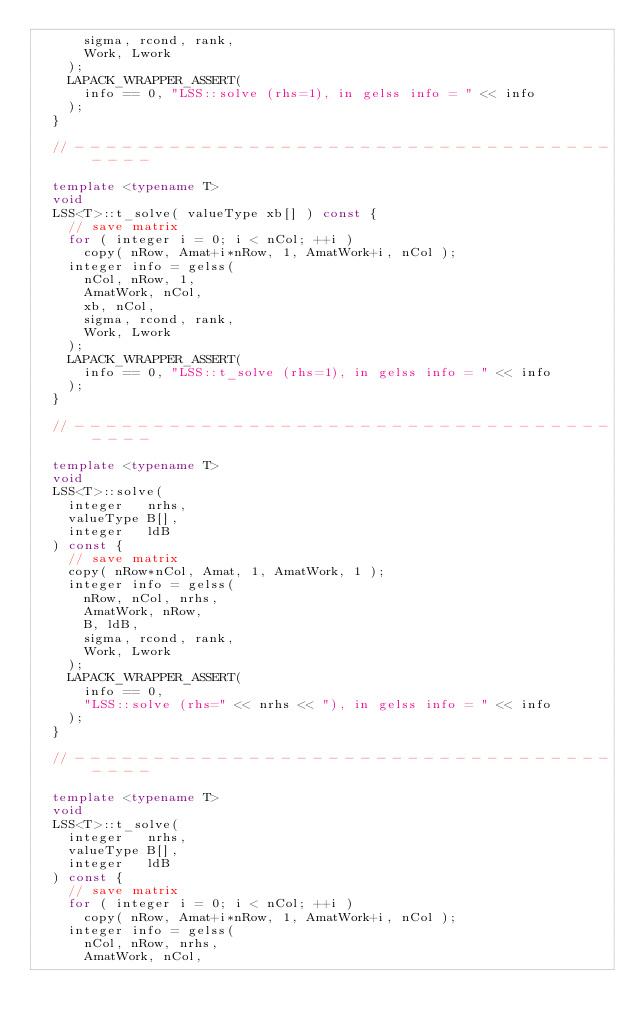Convert code to text. <code><loc_0><loc_0><loc_500><loc_500><_C++_>      sigma, rcond, rank,
      Work, Lwork
    );
    LAPACK_WRAPPER_ASSERT(
      info == 0, "LSS::solve (rhs=1), in gelss info = " << info
    );
  }

  // - - - - - - - - - - - - - - - - - - - - - - - - - - - - - - - - - - - - - -

  template <typename T>
  void
  LSS<T>::t_solve( valueType xb[] ) const {
    // save matrix
    for ( integer i = 0; i < nCol; ++i )
      copy( nRow, Amat+i*nRow, 1, AmatWork+i, nCol );
    integer info = gelss(
      nCol, nRow, 1,
      AmatWork, nCol,
      xb, nCol,
      sigma, rcond, rank,
      Work, Lwork
    );
    LAPACK_WRAPPER_ASSERT(
      info == 0, "LSS::t_solve (rhs=1), in gelss info = " << info
    );
  }

  // - - - - - - - - - - - - - - - - - - - - - - - - - - - - - - - - - - - - - -

  template <typename T>
  void
  LSS<T>::solve(
    integer   nrhs,
    valueType B[],
    integer   ldB
  ) const {
    // save matrix
    copy( nRow*nCol, Amat, 1, AmatWork, 1 );
    integer info = gelss(
      nRow, nCol, nrhs,
      AmatWork, nRow,
      B, ldB,
      sigma, rcond, rank,
      Work, Lwork
    );
    LAPACK_WRAPPER_ASSERT(
      info == 0,
      "LSS::solve (rhs=" << nrhs << "), in gelss info = " << info
    );
  }

  // - - - - - - - - - - - - - - - - - - - - - - - - - - - - - - - - - - - - - -

  template <typename T>
  void
  LSS<T>::t_solve(
    integer   nrhs,
    valueType B[],
    integer   ldB
  ) const {
    // save matrix
    for ( integer i = 0; i < nCol; ++i )
      copy( nRow, Amat+i*nRow, 1, AmatWork+i, nCol );
    integer info = gelss(
      nCol, nRow, nrhs,
      AmatWork, nCol,</code> 